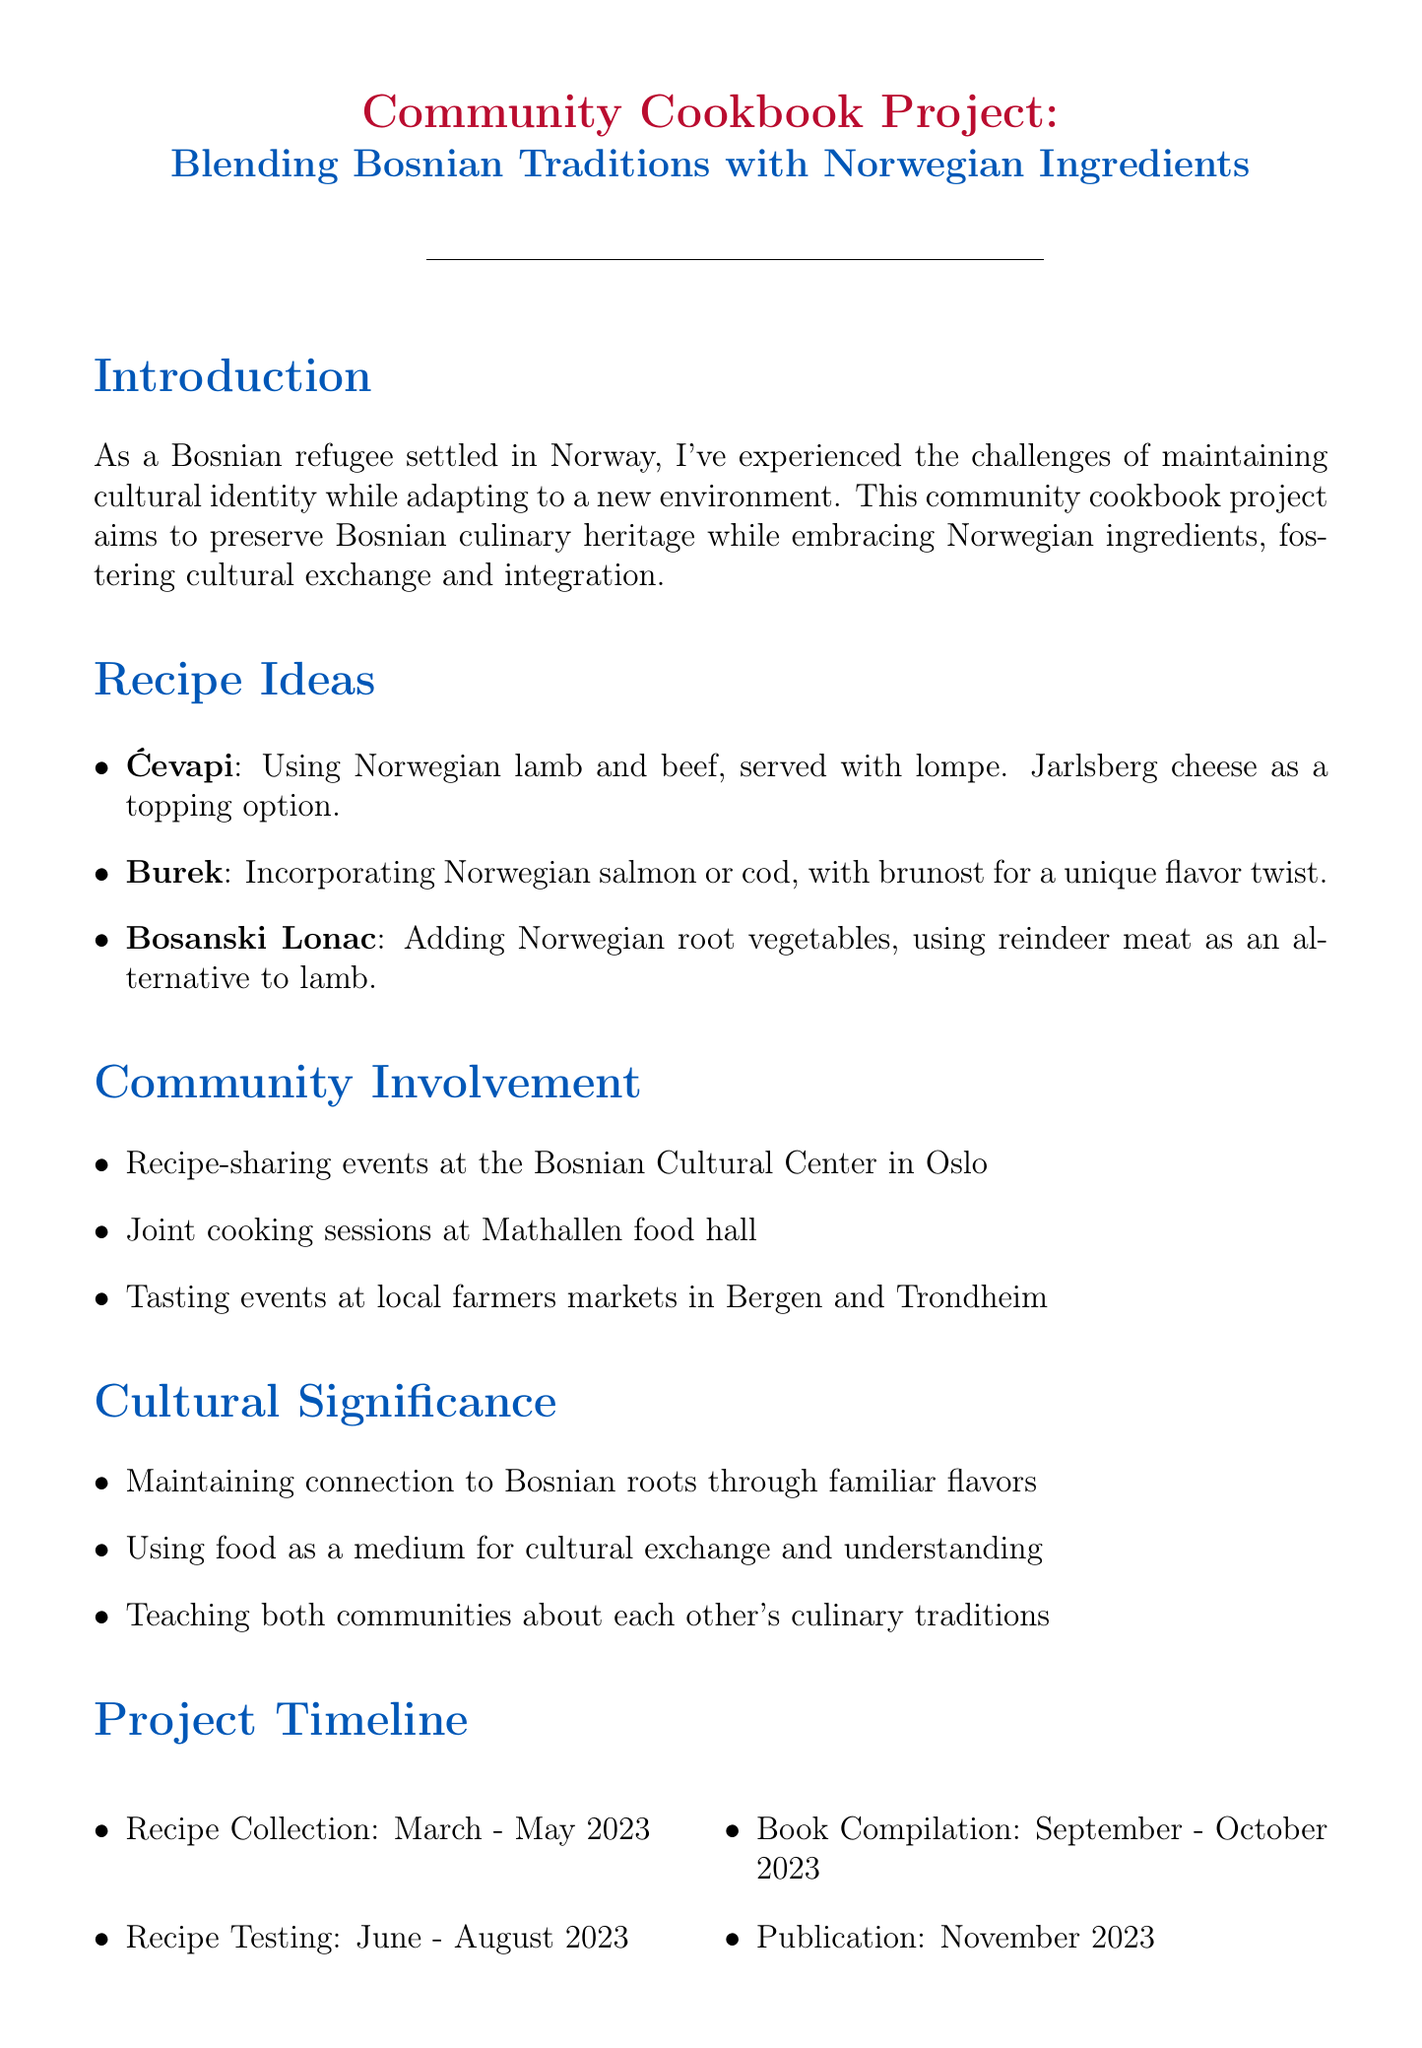What is the title of the project? The title of the project is found at the beginning of the document.
Answer: Community Cookbook Project: Blending Bosnian Traditions with Norwegian Ingredients What is the main aim of the project? The main aim is stated in the introduction section of the document.
Answer: Preserve Bosnian culinary heritage while embracing Norwegian ingredients Which dish uses Norwegian lamb and beef? This detail is provided in the recipe ideas section.
Answer: Ćevapi What is the timeline for recipe collection? The timeline for recipe collection is outlined under the project timeline section.
Answer: March - May 2023 Who are potential partners listed in the project? The potential partners are mentioned in a specific section of the document.
Answer: Norwegian Refugee Council, Samvirkelaget for Bosniere i Norge, MIRA-Senteret, Norges Kokkemesteres Landsforening Which Norwegian ingredient is suggested for Burek? This information can be found in the recipe ideas section for Burek.
Answer: Brunost What type of cookbook is this project based on? The type of cookbook is implied in the introduction and project aim sections.
Answer: Community cookbook What events are suggested for community involvement? Community involvement events are listed in the respective section.
Answer: Recipe-sharing events, joint cooking sessions, tasting events What month is the cookbook publication scheduled for? The cookbook publication month is mentioned in the project timeline section.
Answer: November 2023 